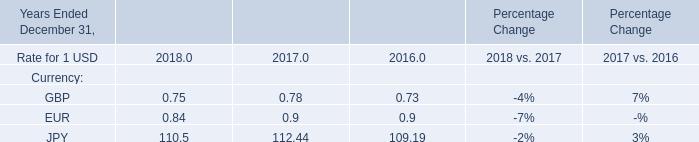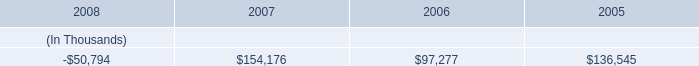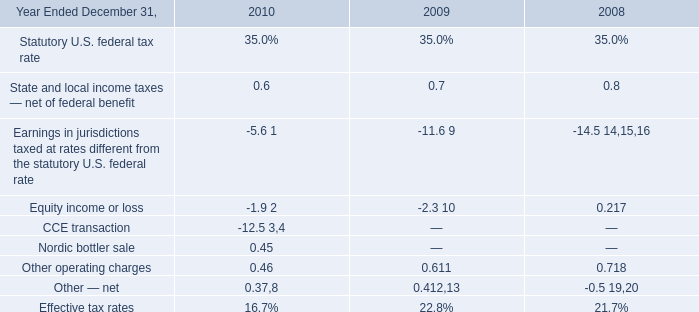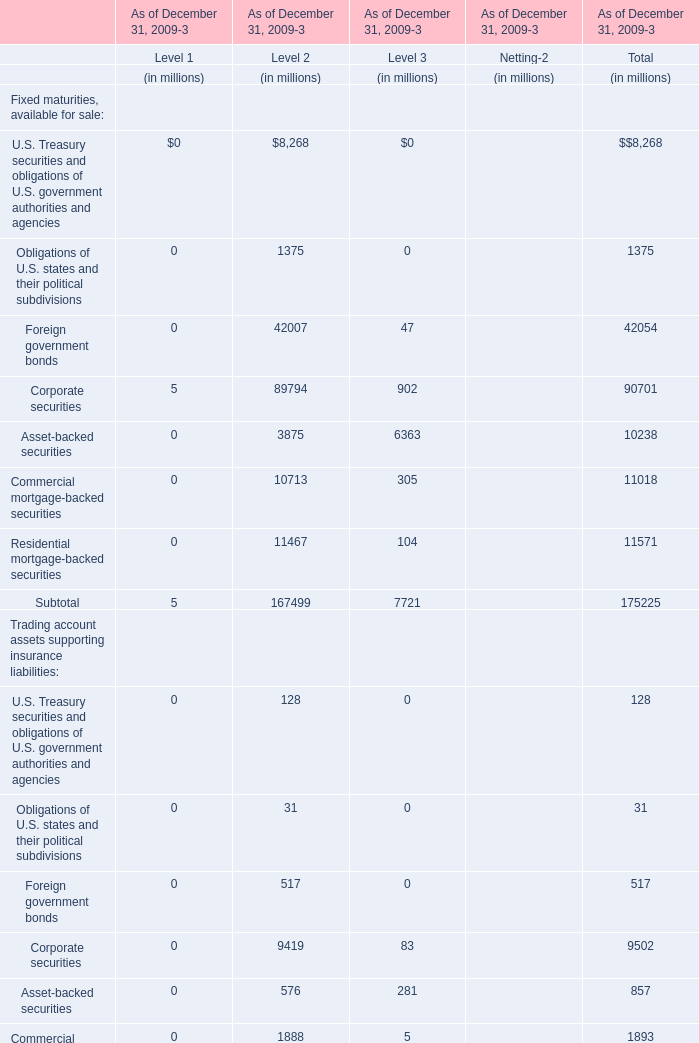What is the Total assets as of December 31, 2009 for the Level where the Total assets as of December 31, 2009 is the least? (in million) 
Answer: 22912. 